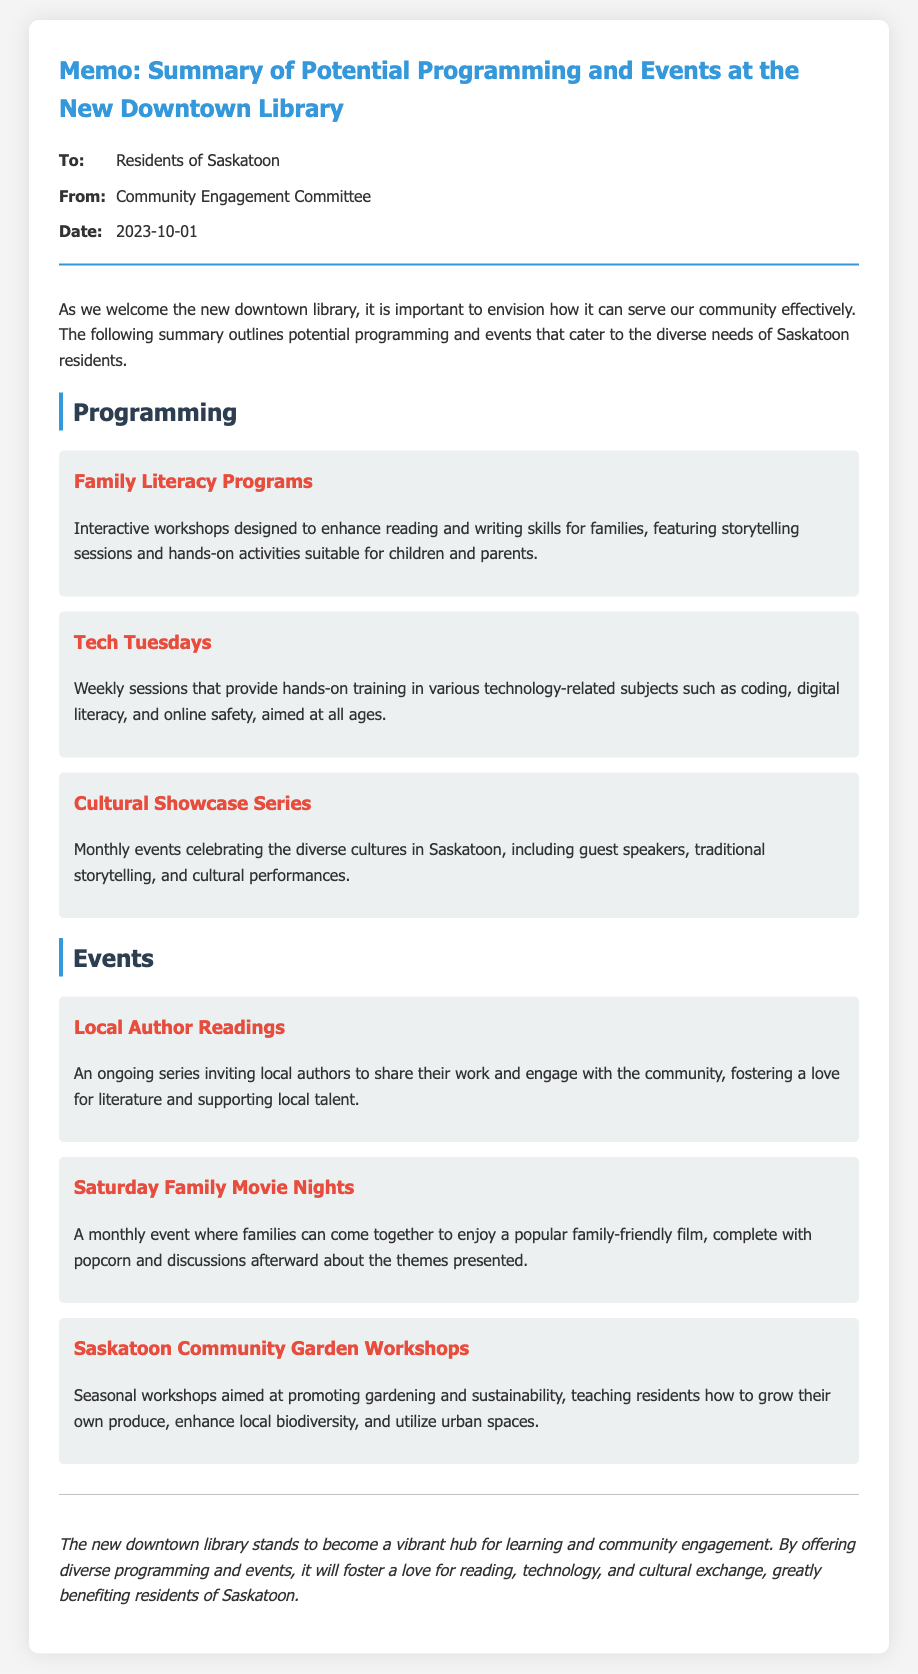what is the title of the memo? The title of the memo is stated at the top, indicating its main subject.
Answer: Memo: Summary of Potential Programming and Events at the New Downtown Library who is the memo addressed to? The "To" section of the memo specifies the intended audience for the document.
Answer: Residents of Saskatoon what is one type of programming offered? The document lists various types of programming, and this question asks for an example from that list.
Answer: Family Literacy Programs how often does the Cultural Showcase Series occur? The document indicates a schedule for this series, which clarifies its frequency.
Answer: Monthly what is the purpose of Tech Tuesdays? By reading the section on Tech Tuesdays, we can determine its intended focus.
Answer: Hands-on training in technology-related subjects how many types of events are mentioned? The document outlines specific events, and this question requires counting those provided in the text.
Answer: Three what is the conclusion about the new downtown library's role? The conclusion summarizes the overall purpose and vision of the new library.
Answer: A vibrant hub for learning and community engagement who authored the memo? The "From" section lists the authoring body responsible for creating the memo.
Answer: Community Engagement Committee 